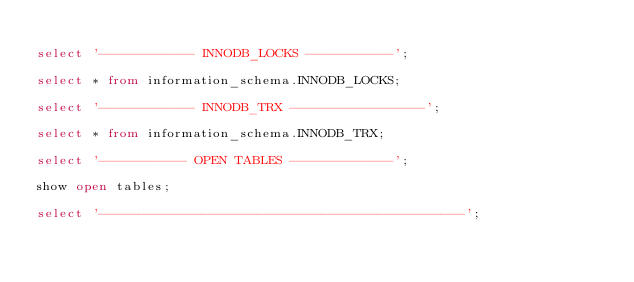<code> <loc_0><loc_0><loc_500><loc_500><_SQL_>
select '------------ INNODB_LOCKS -----------';

select * from information_schema.INNODB_LOCKS;

select '------------ INNODB_TRX -----------------';

select * from information_schema.INNODB_TRX;

select '----------- OPEN TABLES -------------';

show open tables;

select '----------------------------------------------';</code> 